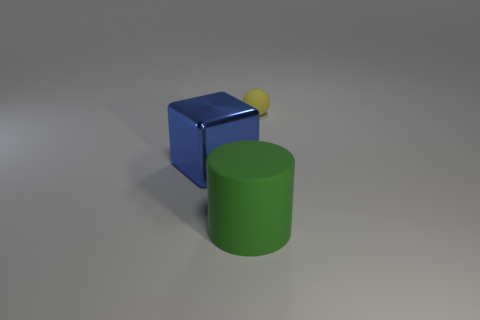What is the color of the rubber cylinder?
Ensure brevity in your answer.  Green. There is a rubber thing that is right of the matte thing that is in front of the yellow sphere; what is its color?
Make the answer very short. Yellow. Are there any other balls that have the same material as the small yellow ball?
Make the answer very short. No. There is a thing on the left side of the big object in front of the big blue object; what is it made of?
Ensure brevity in your answer.  Metal. What number of shiny things have the same shape as the tiny rubber thing?
Ensure brevity in your answer.  0. The yellow thing has what shape?
Your answer should be very brief. Sphere. Is the number of green rubber cylinders less than the number of tiny yellow metal cylinders?
Keep it short and to the point. No. Are there any other things that are the same size as the blue thing?
Provide a succinct answer. Yes. Is the number of shiny things greater than the number of objects?
Offer a terse response. No. Is the tiny thing made of the same material as the blue object that is on the left side of the large green rubber object?
Ensure brevity in your answer.  No. 